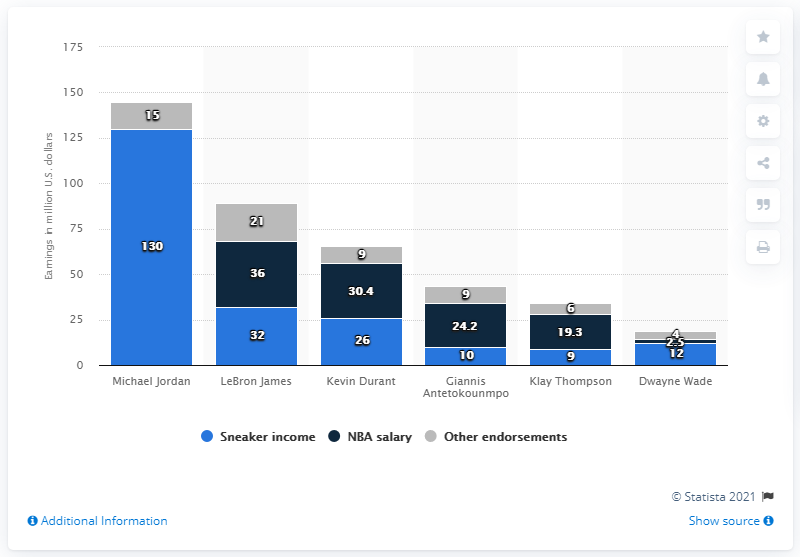Highlight a few significant elements in this photo. In 2019, Michael Jordan earned approximately 130 million dollars from his Jordan brand. It is widely acknowledged that Michael Jordan is one of the most successful basketball players of all time. 